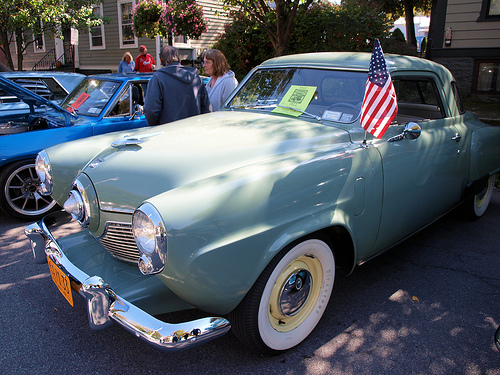<image>
Is the flag to the left of the car? No. The flag is not to the left of the car. From this viewpoint, they have a different horizontal relationship. Where is the car in relation to the hood? Is it behind the hood? Yes. From this viewpoint, the car is positioned behind the hood, with the hood partially or fully occluding the car. 